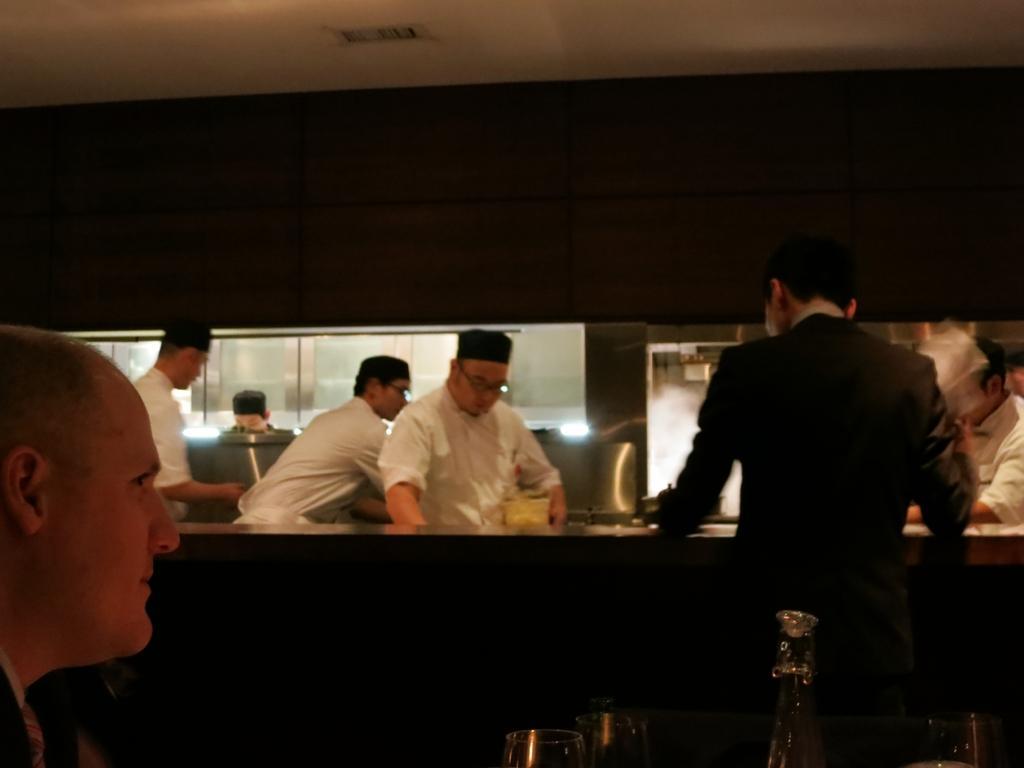Could you give a brief overview of what you see in this image? This picture describes about group of people, a man is seated and few people are standing, in the middle of the image we can see glasses and bottle. 